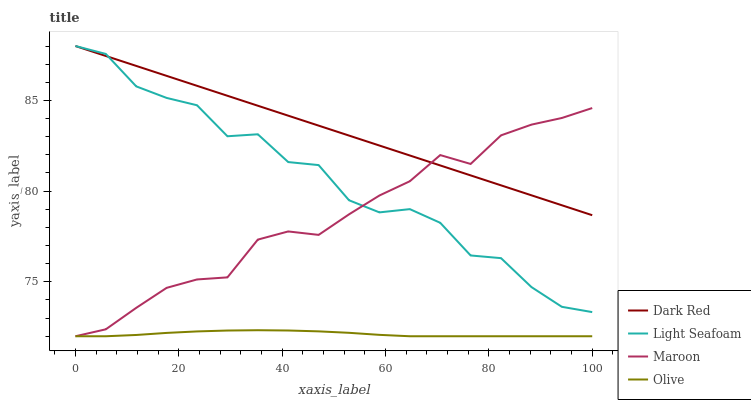Does Olive have the minimum area under the curve?
Answer yes or no. Yes. Does Dark Red have the maximum area under the curve?
Answer yes or no. Yes. Does Light Seafoam have the minimum area under the curve?
Answer yes or no. No. Does Light Seafoam have the maximum area under the curve?
Answer yes or no. No. Is Dark Red the smoothest?
Answer yes or no. Yes. Is Light Seafoam the roughest?
Answer yes or no. Yes. Is Light Seafoam the smoothest?
Answer yes or no. No. Is Dark Red the roughest?
Answer yes or no. No. Does Olive have the lowest value?
Answer yes or no. Yes. Does Light Seafoam have the lowest value?
Answer yes or no. No. Does Light Seafoam have the highest value?
Answer yes or no. Yes. Does Maroon have the highest value?
Answer yes or no. No. Is Olive less than Light Seafoam?
Answer yes or no. Yes. Is Dark Red greater than Olive?
Answer yes or no. Yes. Does Light Seafoam intersect Dark Red?
Answer yes or no. Yes. Is Light Seafoam less than Dark Red?
Answer yes or no. No. Is Light Seafoam greater than Dark Red?
Answer yes or no. No. Does Olive intersect Light Seafoam?
Answer yes or no. No. 